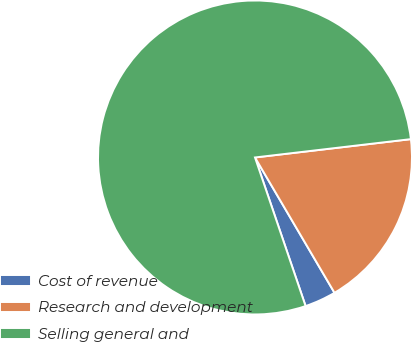<chart> <loc_0><loc_0><loc_500><loc_500><pie_chart><fcel>Cost of revenue<fcel>Research and development<fcel>Selling general and<nl><fcel>3.23%<fcel>18.41%<fcel>78.36%<nl></chart> 